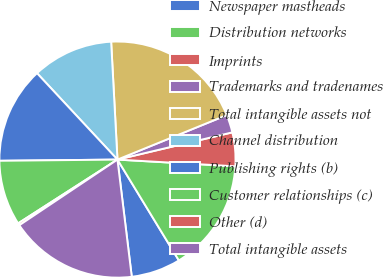<chart> <loc_0><loc_0><loc_500><loc_500><pie_chart><fcel>Newspaper mastheads<fcel>Distribution networks<fcel>Imprints<fcel>Trademarks and tradenames<fcel>Total intangible assets not<fcel>Channel distribution<fcel>Publishing rights (b)<fcel>Customer relationships (c)<fcel>Other (d)<fcel>Total intangible assets<nl><fcel>6.77%<fcel>15.39%<fcel>4.61%<fcel>2.45%<fcel>19.7%<fcel>11.08%<fcel>13.23%<fcel>8.92%<fcel>0.3%<fcel>17.55%<nl></chart> 